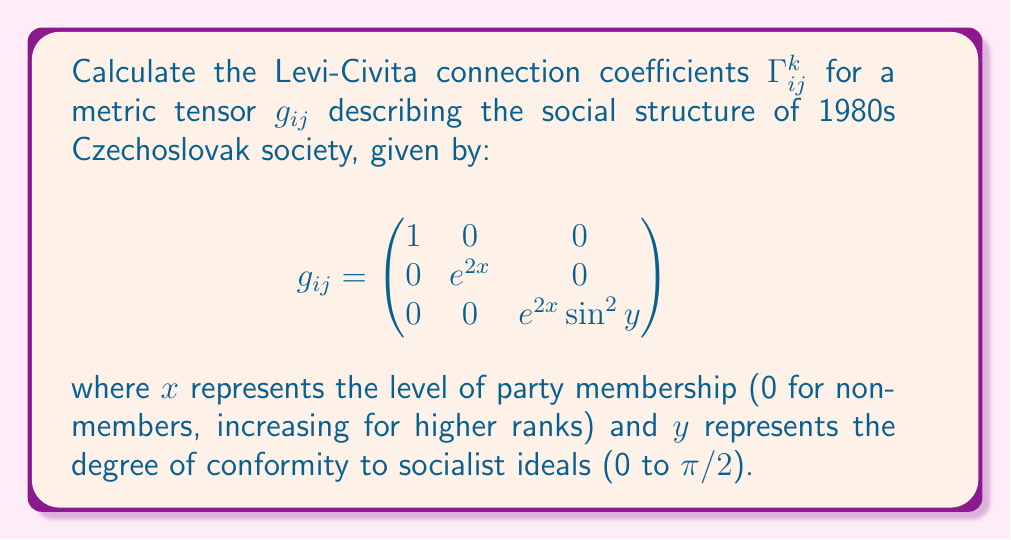Teach me how to tackle this problem. To calculate the Levi-Civita connection coefficients, we'll use the formula:

$$\Gamma^k_{ij} = \frac{1}{2}g^{kl}\left(\frac{\partial g_{jl}}{\partial x^i} + \frac{\partial g_{il}}{\partial x^j} - \frac{\partial g_{ij}}{\partial x^l}\right)$$

Step 1: Calculate the inverse metric tensor $g^{ij}$:
$$g^{ij} = \begin{pmatrix}
1 & 0 & 0 \\
0 & e^{-2x} & 0 \\
0 & 0 & \frac{1}{e^{2x}\sin^2y}
\end{pmatrix}$$

Step 2: Calculate the partial derivatives of $g_{ij}$:
$\frac{\partial g_{22}}{\partial x} = 2e^{2x}$
$\frac{\partial g_{33}}{\partial x} = 2e^{2x}\sin^2y$
$\frac{\partial g_{33}}{\partial y} = 2e^{2x}\sin y \cos y$

Step 3: Apply the formula for each non-zero component:

$\Gamma^1_{22} = \frac{1}{2}g^{11}(-\frac{\partial g_{22}}{\partial x}) = -e^{2x}$

$\Gamma^1_{33} = \frac{1}{2}g^{11}(-\frac{\partial g_{33}}{\partial x}) = -e^{2x}\sin^2y$

$\Gamma^2_{12} = \Gamma^2_{21} = \frac{1}{2}g^{22}(\frac{\partial g_{22}}{\partial x}) = 1$

$\Gamma^3_{13} = \Gamma^3_{31} = \frac{1}{2}g^{33}(\frac{\partial g_{33}}{\partial x}) = 1$

$\Gamma^3_{23} = \Gamma^3_{32} = \frac{1}{2}g^{33}(\frac{\partial g_{33}}{\partial y}) = \cot y$

All other components are zero.

These coefficients describe how the social structure changes as one moves through different levels of party membership and conformity in 1980s Czechoslovak society.
Answer: $\Gamma^1_{22} = -e^{2x}$, $\Gamma^1_{33} = -e^{2x}\sin^2y$, $\Gamma^2_{12} = \Gamma^2_{21} = 1$, $\Gamma^3_{13} = \Gamma^3_{31} = 1$, $\Gamma^3_{23} = \Gamma^3_{32} = \cot y$, others zero. 